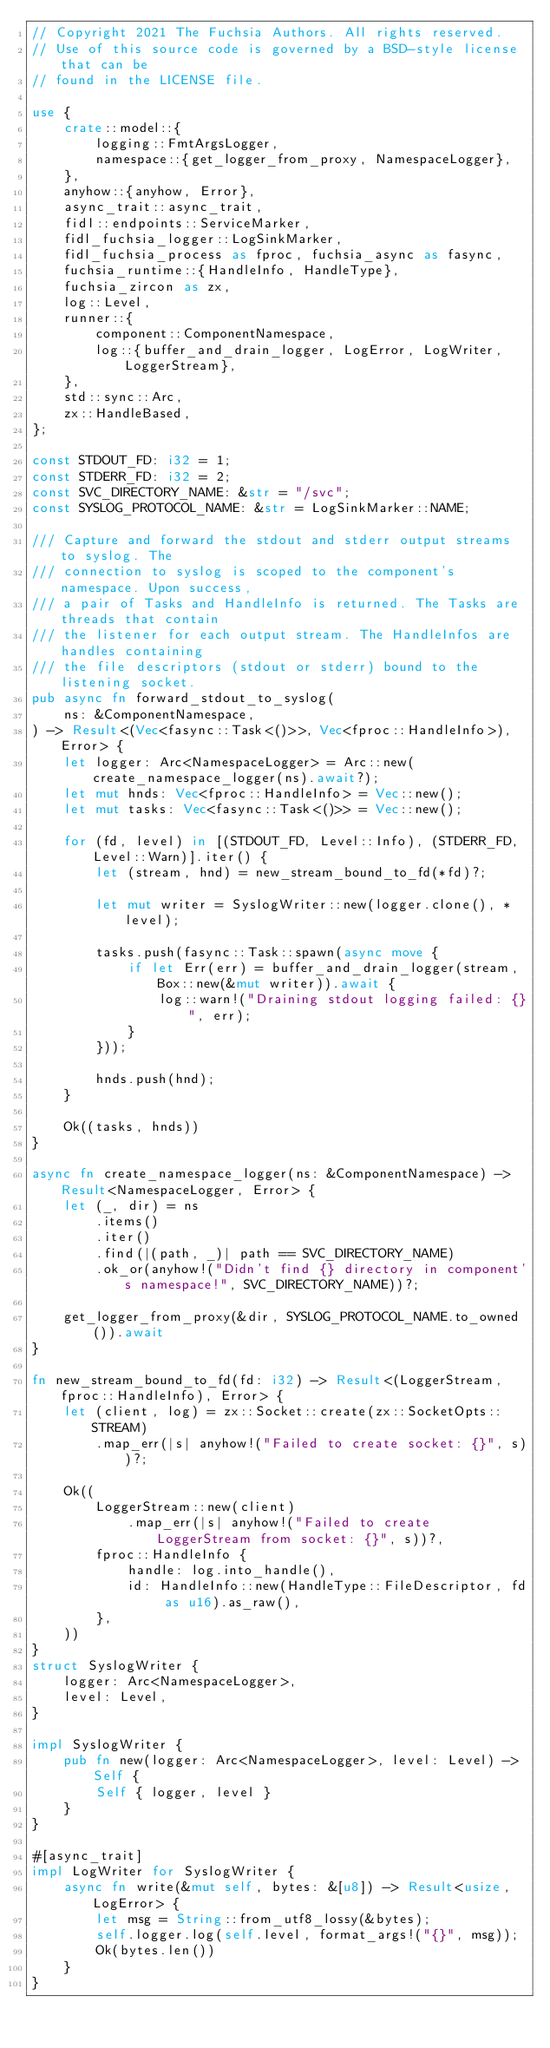<code> <loc_0><loc_0><loc_500><loc_500><_Rust_>// Copyright 2021 The Fuchsia Authors. All rights reserved.
// Use of this source code is governed by a BSD-style license that can be
// found in the LICENSE file.

use {
    crate::model::{
        logging::FmtArgsLogger,
        namespace::{get_logger_from_proxy, NamespaceLogger},
    },
    anyhow::{anyhow, Error},
    async_trait::async_trait,
    fidl::endpoints::ServiceMarker,
    fidl_fuchsia_logger::LogSinkMarker,
    fidl_fuchsia_process as fproc, fuchsia_async as fasync,
    fuchsia_runtime::{HandleInfo, HandleType},
    fuchsia_zircon as zx,
    log::Level,
    runner::{
        component::ComponentNamespace,
        log::{buffer_and_drain_logger, LogError, LogWriter, LoggerStream},
    },
    std::sync::Arc,
    zx::HandleBased,
};

const STDOUT_FD: i32 = 1;
const STDERR_FD: i32 = 2;
const SVC_DIRECTORY_NAME: &str = "/svc";
const SYSLOG_PROTOCOL_NAME: &str = LogSinkMarker::NAME;

/// Capture and forward the stdout and stderr output streams to syslog. The
/// connection to syslog is scoped to the component's namespace. Upon success,
/// a pair of Tasks and HandleInfo is returned. The Tasks are threads that contain
/// the listener for each output stream. The HandleInfos are handles containing
/// the file descriptors (stdout or stderr) bound to the listening socket.
pub async fn forward_stdout_to_syslog(
    ns: &ComponentNamespace,
) -> Result<(Vec<fasync::Task<()>>, Vec<fproc::HandleInfo>), Error> {
    let logger: Arc<NamespaceLogger> = Arc::new(create_namespace_logger(ns).await?);
    let mut hnds: Vec<fproc::HandleInfo> = Vec::new();
    let mut tasks: Vec<fasync::Task<()>> = Vec::new();

    for (fd, level) in [(STDOUT_FD, Level::Info), (STDERR_FD, Level::Warn)].iter() {
        let (stream, hnd) = new_stream_bound_to_fd(*fd)?;

        let mut writer = SyslogWriter::new(logger.clone(), *level);

        tasks.push(fasync::Task::spawn(async move {
            if let Err(err) = buffer_and_drain_logger(stream, Box::new(&mut writer)).await {
                log::warn!("Draining stdout logging failed: {}", err);
            }
        }));

        hnds.push(hnd);
    }

    Ok((tasks, hnds))
}

async fn create_namespace_logger(ns: &ComponentNamespace) -> Result<NamespaceLogger, Error> {
    let (_, dir) = ns
        .items()
        .iter()
        .find(|(path, _)| path == SVC_DIRECTORY_NAME)
        .ok_or(anyhow!("Didn't find {} directory in component's namespace!", SVC_DIRECTORY_NAME))?;

    get_logger_from_proxy(&dir, SYSLOG_PROTOCOL_NAME.to_owned()).await
}

fn new_stream_bound_to_fd(fd: i32) -> Result<(LoggerStream, fproc::HandleInfo), Error> {
    let (client, log) = zx::Socket::create(zx::SocketOpts::STREAM)
        .map_err(|s| anyhow!("Failed to create socket: {}", s))?;

    Ok((
        LoggerStream::new(client)
            .map_err(|s| anyhow!("Failed to create LoggerStream from socket: {}", s))?,
        fproc::HandleInfo {
            handle: log.into_handle(),
            id: HandleInfo::new(HandleType::FileDescriptor, fd as u16).as_raw(),
        },
    ))
}
struct SyslogWriter {
    logger: Arc<NamespaceLogger>,
    level: Level,
}

impl SyslogWriter {
    pub fn new(logger: Arc<NamespaceLogger>, level: Level) -> Self {
        Self { logger, level }
    }
}

#[async_trait]
impl LogWriter for SyslogWriter {
    async fn write(&mut self, bytes: &[u8]) -> Result<usize, LogError> {
        let msg = String::from_utf8_lossy(&bytes);
        self.logger.log(self.level, format_args!("{}", msg));
        Ok(bytes.len())
    }
}
</code> 